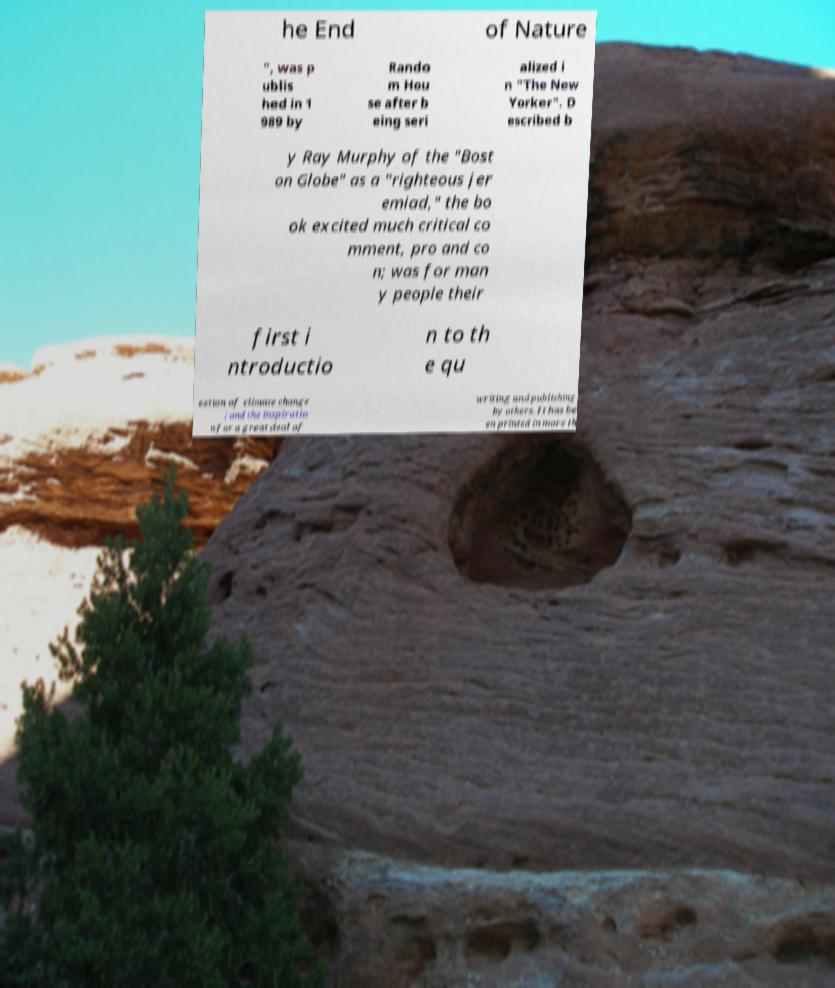Could you extract and type out the text from this image? he End of Nature ", was p ublis hed in 1 989 by Rando m Hou se after b eing seri alized i n "The New Yorker". D escribed b y Ray Murphy of the "Bost on Globe" as a "righteous jer emiad," the bo ok excited much critical co mment, pro and co n; was for man y people their first i ntroductio n to th e qu estion of climate change ; and the inspiratio n for a great deal of writing and publishing by others. It has be en printed in more th 